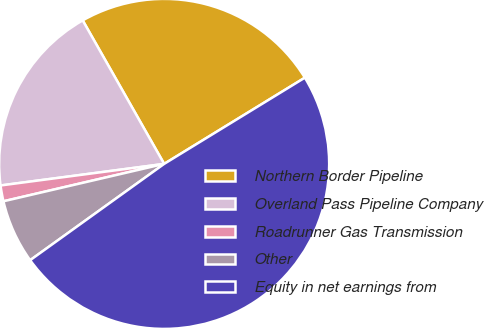Convert chart. <chart><loc_0><loc_0><loc_500><loc_500><pie_chart><fcel>Northern Border Pipeline<fcel>Overland Pass Pipeline Company<fcel>Roadrunner Gas Transmission<fcel>Other<fcel>Equity in net earnings from<nl><fcel>24.47%<fcel>18.87%<fcel>1.55%<fcel>6.28%<fcel>48.83%<nl></chart> 